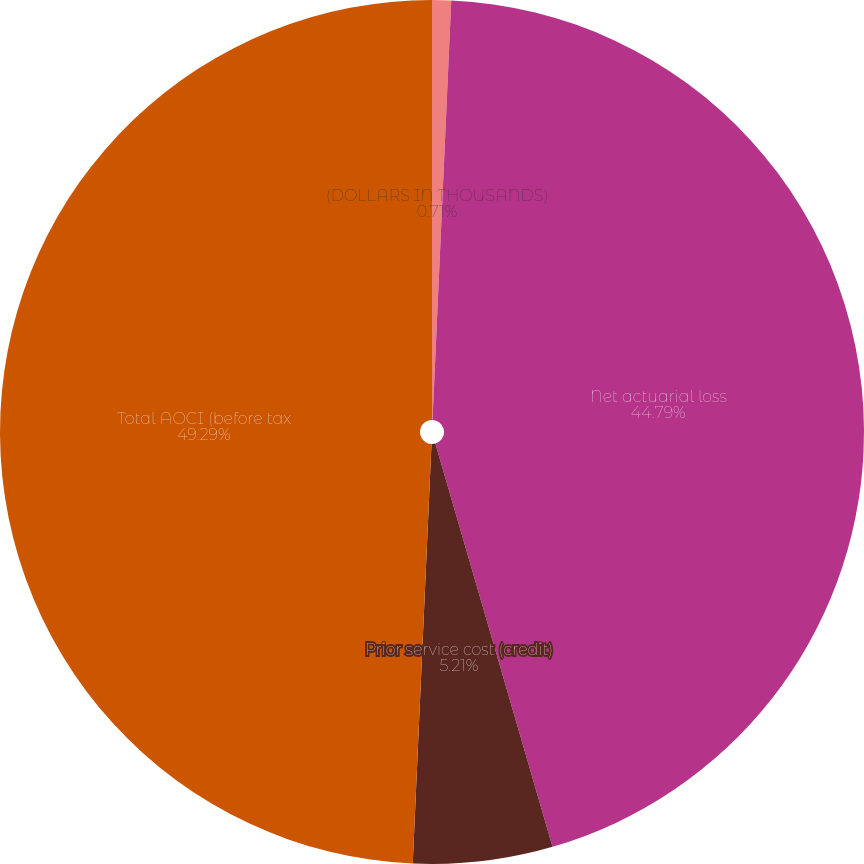Convert chart. <chart><loc_0><loc_0><loc_500><loc_500><pie_chart><fcel>(DOLLARS IN THOUSANDS)<fcel>Net actuarial loss<fcel>Prior service cost (credit)<fcel>Total AOCI (before tax<nl><fcel>0.71%<fcel>44.79%<fcel>5.21%<fcel>49.29%<nl></chart> 